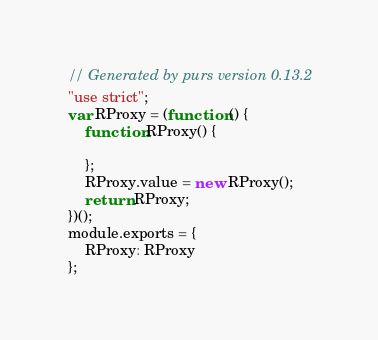<code> <loc_0><loc_0><loc_500><loc_500><_JavaScript_>// Generated by purs version 0.13.2
"use strict";
var RProxy = (function () {
    function RProxy() {

    };
    RProxy.value = new RProxy();
    return RProxy;
})();
module.exports = {
    RProxy: RProxy
};
</code> 